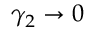<formula> <loc_0><loc_0><loc_500><loc_500>\gamma _ { 2 } \to 0</formula> 